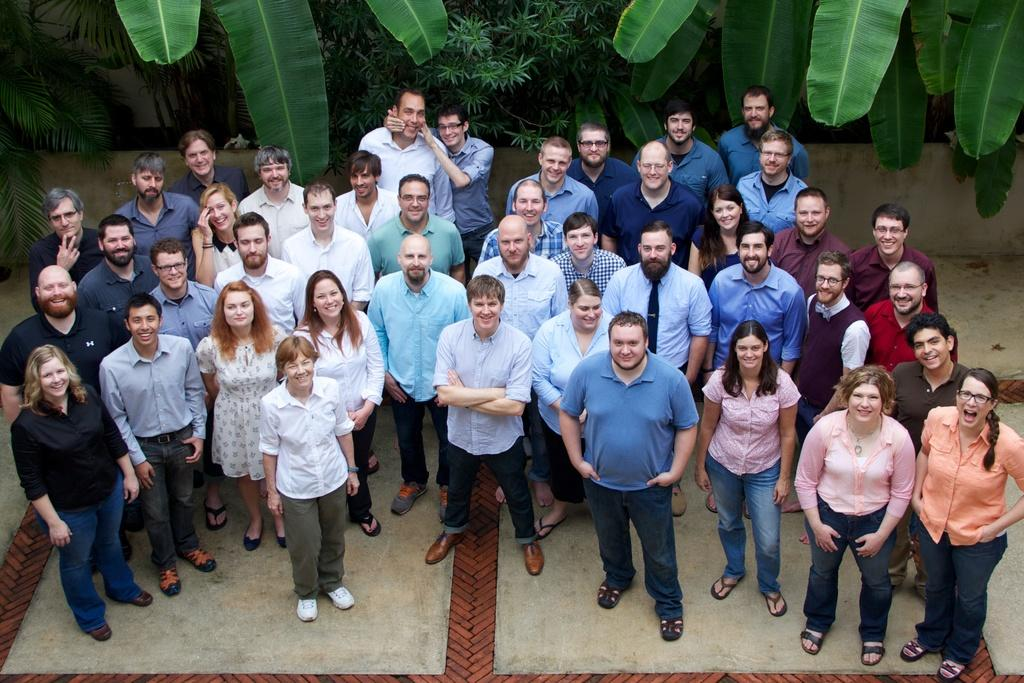How many people are in the image? There is a group of people in the image. What are the people doing in the image? The people are standing on the ground and smiling. What can be seen in the background of the image? There are trees and a wall in the background of the image. What type of peace symbol can be seen in the image? There is no peace symbol present in the image. How many oranges are being held by the people in the image? There are no oranges visible in the image. 